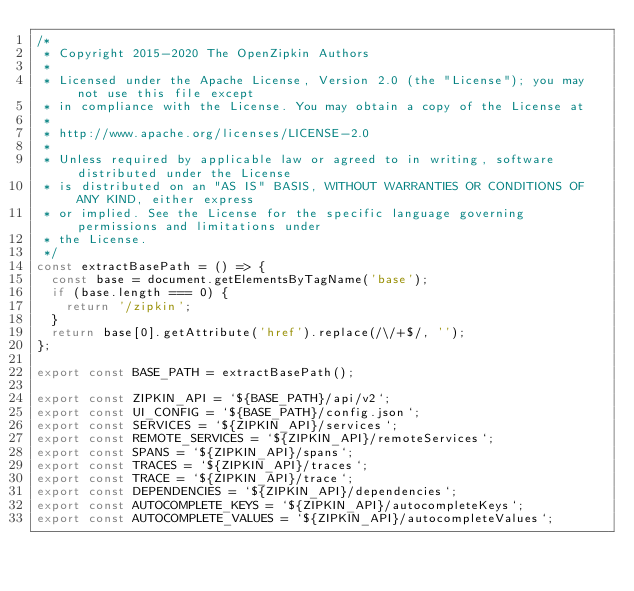Convert code to text. <code><loc_0><loc_0><loc_500><loc_500><_JavaScript_>/*
 * Copyright 2015-2020 The OpenZipkin Authors
 *
 * Licensed under the Apache License, Version 2.0 (the "License"); you may not use this file except
 * in compliance with the License. You may obtain a copy of the License at
 *
 * http://www.apache.org/licenses/LICENSE-2.0
 *
 * Unless required by applicable law or agreed to in writing, software distributed under the License
 * is distributed on an "AS IS" BASIS, WITHOUT WARRANTIES OR CONDITIONS OF ANY KIND, either express
 * or implied. See the License for the specific language governing permissions and limitations under
 * the License.
 */
const extractBasePath = () => {
  const base = document.getElementsByTagName('base');
  if (base.length === 0) {
    return '/zipkin';
  }
  return base[0].getAttribute('href').replace(/\/+$/, '');
};

export const BASE_PATH = extractBasePath();

export const ZIPKIN_API = `${BASE_PATH}/api/v2`;
export const UI_CONFIG = `${BASE_PATH}/config.json`;
export const SERVICES = `${ZIPKIN_API}/services`;
export const REMOTE_SERVICES = `${ZIPKIN_API}/remoteServices`;
export const SPANS = `${ZIPKIN_API}/spans`;
export const TRACES = `${ZIPKIN_API}/traces`;
export const TRACE = `${ZIPKIN_API}/trace`;
export const DEPENDENCIES = `${ZIPKIN_API}/dependencies`;
export const AUTOCOMPLETE_KEYS = `${ZIPKIN_API}/autocompleteKeys`;
export const AUTOCOMPLETE_VALUES = `${ZIPKIN_API}/autocompleteValues`;
</code> 